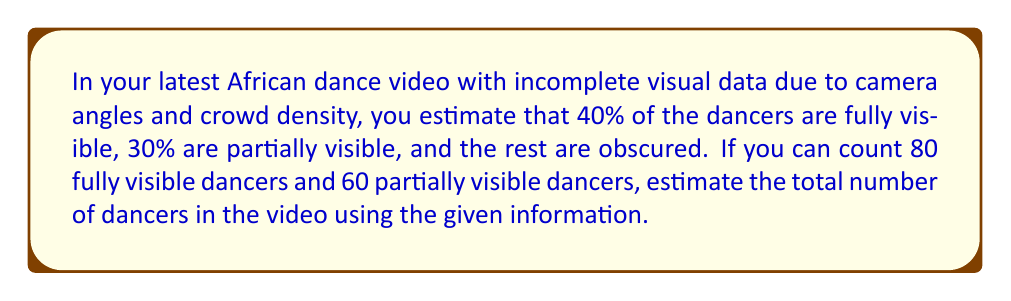Could you help me with this problem? Let's approach this step-by-step:

1) Let $x$ be the total number of dancers in the video.

2) We know that:
   - 40% of $x$ are fully visible
   - 30% of $x$ are partially visible
   - The remaining 30% are obscured

3) We can set up two equations based on the given information:
   - Fully visible: $0.4x = 80$
   - Partially visible: $0.3x = 60$

4) Let's solve using the fully visible equation:
   $0.4x = 80$
   $x = 80 / 0.4 = 200$

5) Let's verify using the partially visible equation:
   $0.3 * 200 = 60$, which matches our given information

6) We can double-check our solution:
   - Fully visible: $40\% \text{ of } 200 = 80$
   - Partially visible: $30\% \text{ of } 200 = 60$
   - Obscured: $30\% \text{ of } 200 = 60$

7) The total adds up: $80 + 60 + 60 = 200$

Therefore, we estimate that there are 200 dancers in the video.
Answer: 200 dancers 